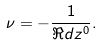<formula> <loc_0><loc_0><loc_500><loc_500>\nu = - \frac { 1 } { \Re d { z ^ { 0 } } } .</formula> 